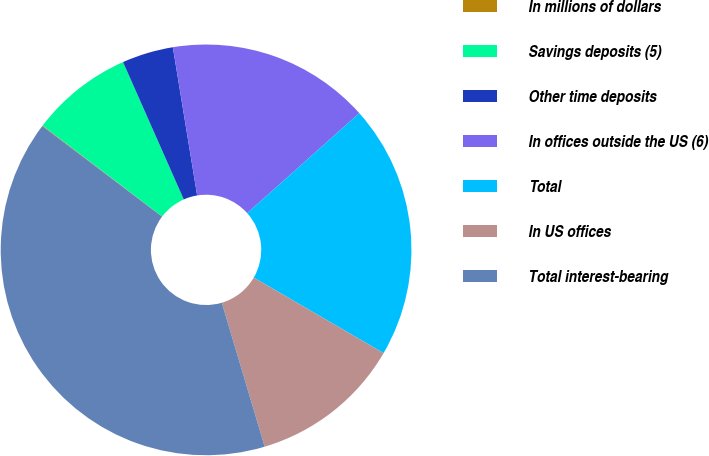Convert chart. <chart><loc_0><loc_0><loc_500><loc_500><pie_chart><fcel>In millions of dollars<fcel>Savings deposits (5)<fcel>Other time deposits<fcel>In offices outside the US (6)<fcel>Total<fcel>In US offices<fcel>Total interest-bearing<nl><fcel>0.05%<fcel>8.02%<fcel>4.04%<fcel>15.99%<fcel>19.98%<fcel>12.01%<fcel>39.91%<nl></chart> 